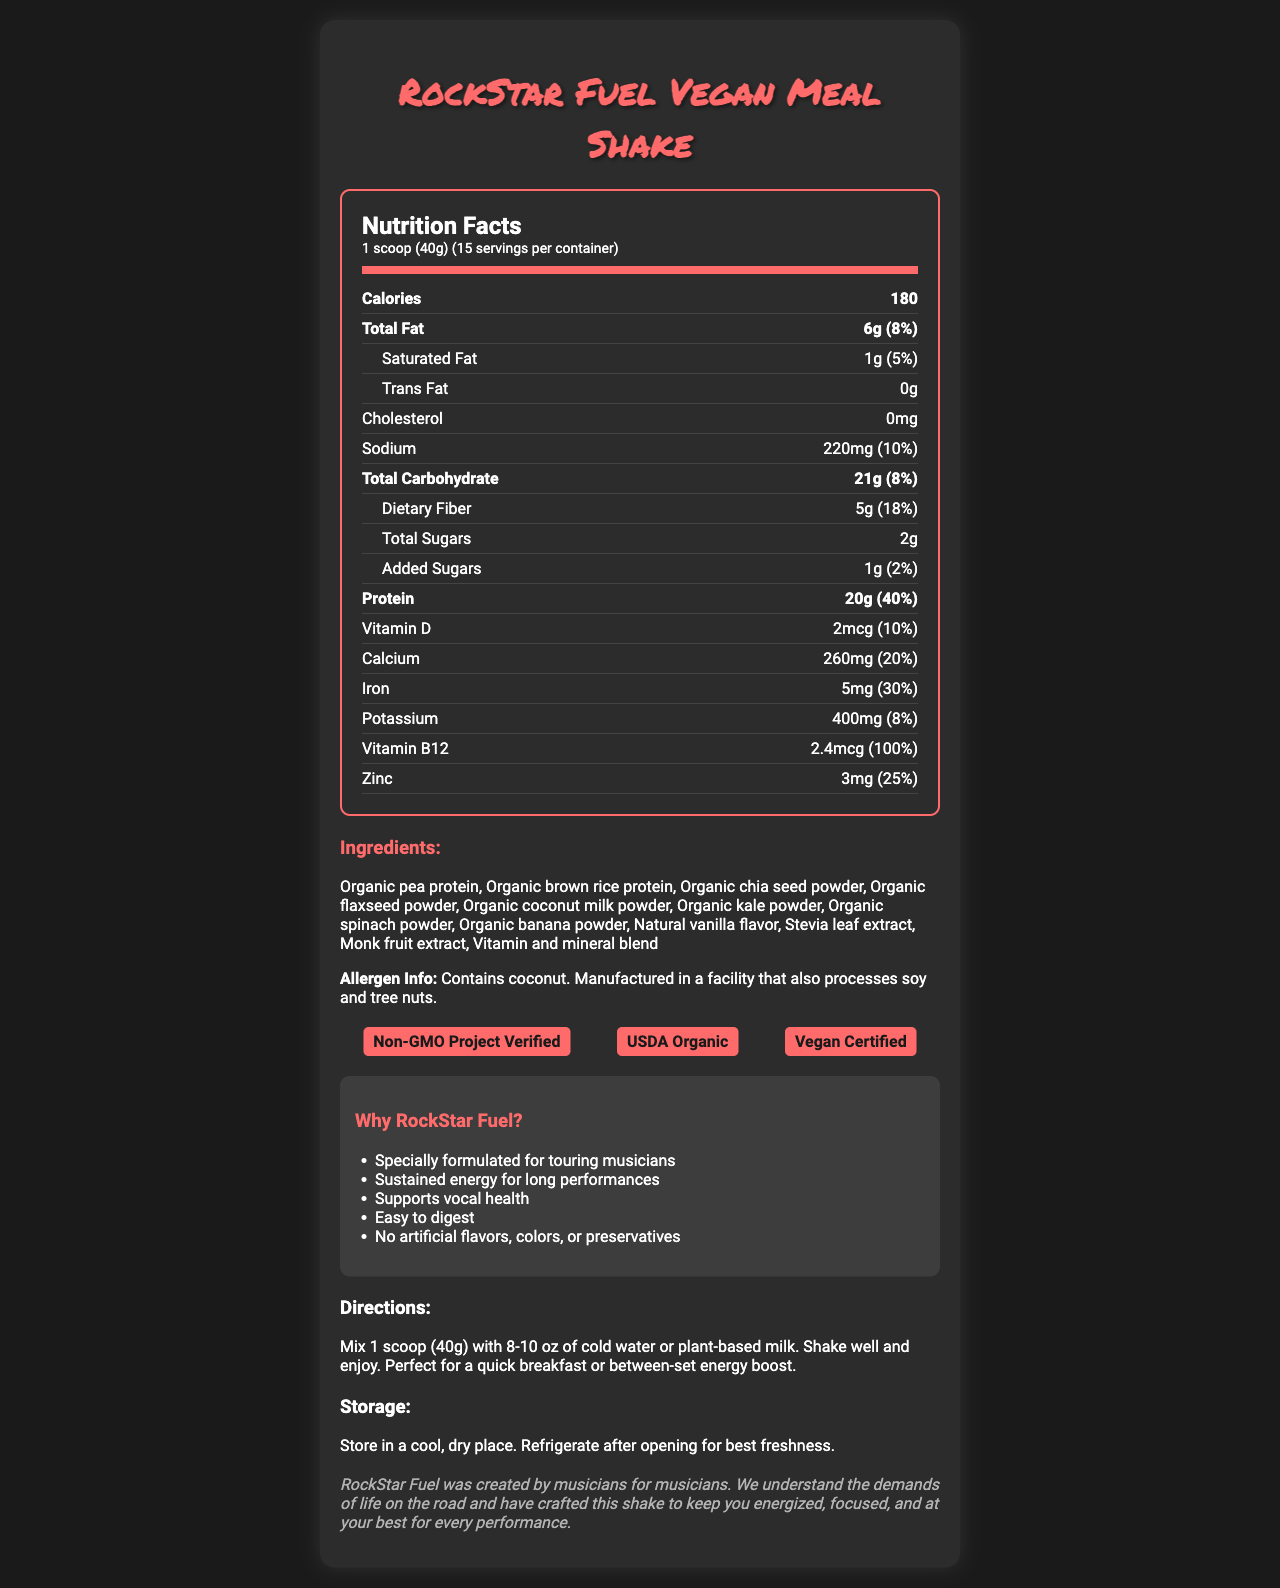what is the serving size of RockStar Fuel Vegan Meal Shake? The serving size is clearly stated as "1 scoop (40g)" at the top of the nutrition label.
Answer: 1 scoop (40g) how many servings are there per container? The serving size indicates that each container has 15 servings.
Answer: 15 how many calories are in one serving? It states that each serving contains 180 calories.
Answer: 180 how much protein is in a serving? The nutrition label lists 20g of protein per serving.
Answer: 20g how much is the added sugars' percent daily value? The document lists added sugars as 1g, which is 2% of the daily value.
Answer: 2% which has higher daily value percentage: calcium or iron? A. Calcium B. Iron Iron has a daily value percentage of 30%, whereas calcium has 20%.
Answer: B. Iron what are the main sources of protein in this shake? The ingredients list mentions Organic pea protein and Organic brown rice protein as the first two ingredients, which are typically the main sources of protein.
Answer: Organic pea protein and Organic brown rice protein is there any cholesterol in a serving of RockStar Fuel Vegan Meal Shake? The document states that the shake contains 0mg of cholesterol.
Answer: No does this product contain any artificial flavors or preservatives? One of the marketing claims states "No artificial flavors, colors, or preservatives."
Answer: No describe the certifications and the allergen information for the product The document highlights the certifications under a separate section and specifically states the allergen information below the ingredients.
Answer: The product is Non-GMO Project Verified, USDA Organic, and Vegan Certified. It contains coconut and is manufactured in a facility that also processes soy and tree nuts. is RockStar Fuel Vegan Meal Shake suitable for a vegan diet? The product is labeled as "Vegan Certified," indicating it is suitable for a vegan diet.
Answer: Yes how does RockStar Fuel claim to benefit touring musicians? The marketing claims section lists these specific benefits tailored for touring musicians.
Answer: Specially formulated for touring musicians, Sustained energy for long performances, Supports vocal health, Easy to digest what's the recommended storage condition for this shake? The storage instructions recommend storing in a cool, dry place and refrigerating after opening for best freshness.
Answer: Store in a cool, dry place. Refrigerate after opening for best freshness. why is this product marketed as easy to digest? Even though the document claims that the product is easy to digest, it lacks detailed reasons or supporting information.
Answer: The marketing claims state that it's "Easy to digest," but do not provide further detail in the document. how much potassium is in each serving, and what percent of the daily value does that represent? The nutrition label states that each serving contains 400mg of potassium, which is 8% of the daily value.
Answer: 400mg, 8% how many marketing claims are made about this product? The marketing claims section lists five different claims.
Answer: 5 what is the story behind the brand RockStar Fuel? The brand story section provides this background, emphasizing its creation by and for musicians.
Answer: RockStar Fuel was created by musicians for musicians to keep them energized, focused, and at their best for every performance. what are the main features of the RockStar Fuel Vegan Meal Shake described in the document? This summary covers the product’s purpose, key benefits, certifications, nutritional content, and other essential information mentioned in the document.
Answer: RockStar Fuel Vegan Meal Shake is a meal replacement shake designed for touring musicians. It provides sustained energy for performances, supports vocal health, and is easy to digest. The product is vegan-certified, non-GMO, and USDA organic. The shake contains various nutrients such as proteins, vitamins, and minerals and is free from artificial flavors, colors, and preservatives. It also provides specific storage and usage instructions for best results. 